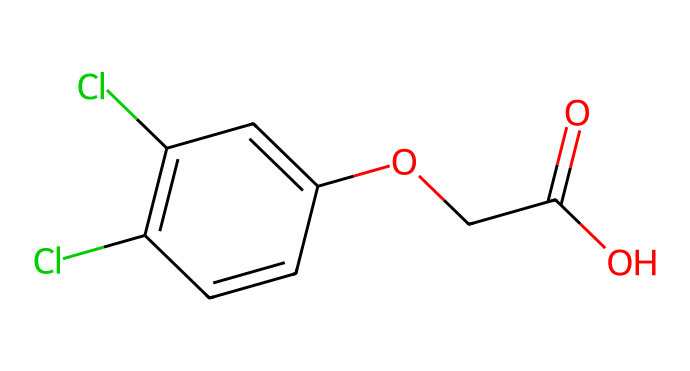What is the molecular formula of 2,4-Dichlorophenoxyacetic acid? To determine the molecular formula, we analyze the SMILES representation. Counting the atoms gives us 8 carbons (C), 6 hydrogens (H), 4 chlorines (Cl), and 4 oxygens (O). Thus, the molecular formula is C8H6Cl2O3.
Answer: C8H6Cl2O3 How many chlorine atoms are present in 2,4-D? The SMILES structure indicates two chlorine (Cl) atoms directly attached in the ring and phenoxy group, which are easily identifiable from the formula.
Answer: 2 What type of functional groups does 2,4-Dichlorophenoxyacetic acid contain? The structure shows it contains a carboxylic acid (-COOH) and an ether linkage (O-C). These functional groups are key features in the chemical's activity.
Answer: carboxylic acid, ether Is 2,4-D a polar or non-polar molecule? By examining the presence of functional groups, such as the carboxylic acid and the electronegative chlorine atoms, we can conclude that the molecule overall has polar characteristics due to the unequal distribution of electron density.
Answer: polar What is the role of 2,4-D in agriculture? 2,4-D is used as a selective herbicide, primarily for controlling broadleaf weeds without harming grasses, facilitated by its unique chemical structure allowing for specific herbicidal action.
Answer: selective herbicide How many rings are present in the structure of 2,4-D? The SMILES indicate a single aromatic ring, which is characterized by the conjugated double bonds in the phenyl part of the structure. This indicates the presence of one ring in its structure.
Answer: 1 